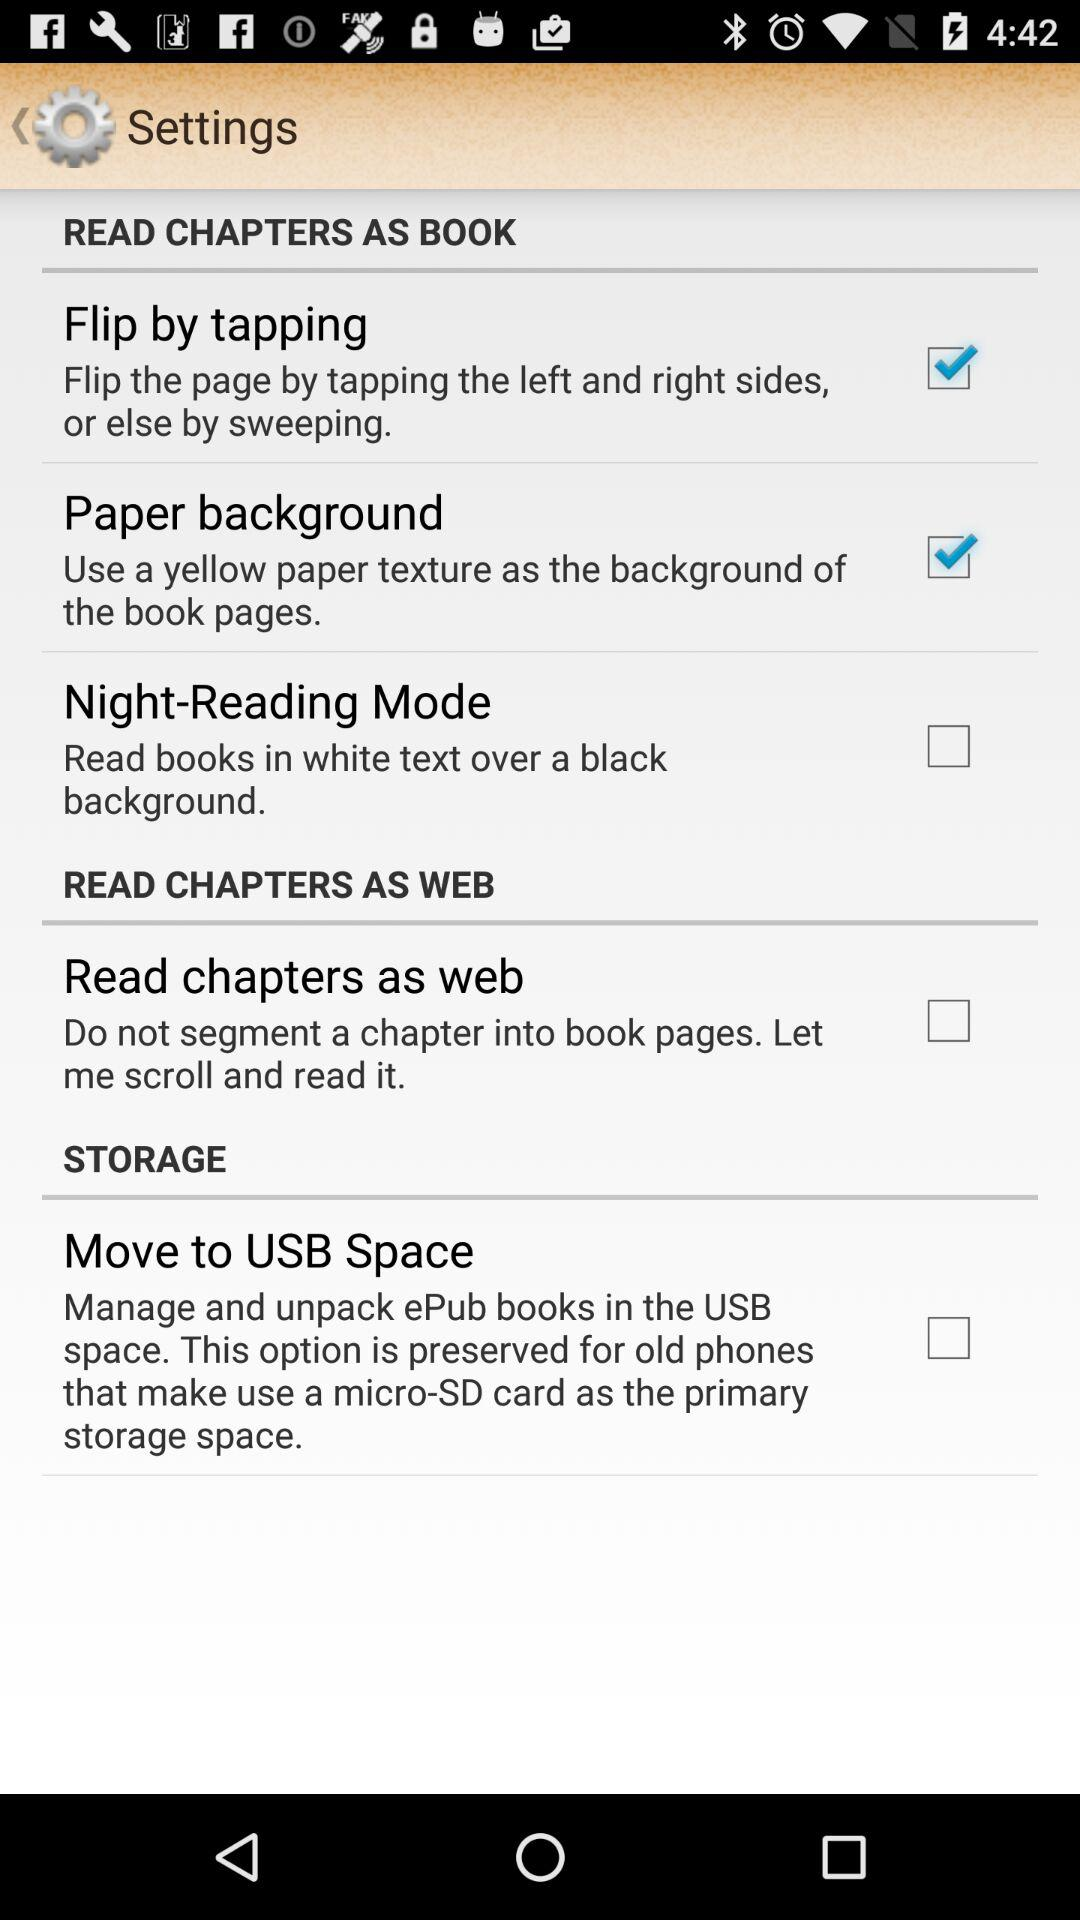What is the status of Paper background? The status of the Paper background is Checked. 